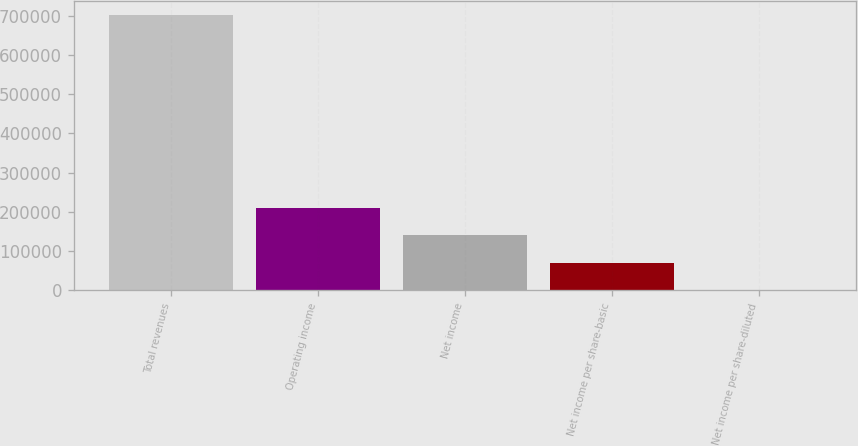Convert chart to OTSL. <chart><loc_0><loc_0><loc_500><loc_500><bar_chart><fcel>Total revenues<fcel>Operating income<fcel>Net income<fcel>Net income per share-basic<fcel>Net income per share-diluted<nl><fcel>701833<fcel>210550<fcel>140367<fcel>70183.5<fcel>0.25<nl></chart> 